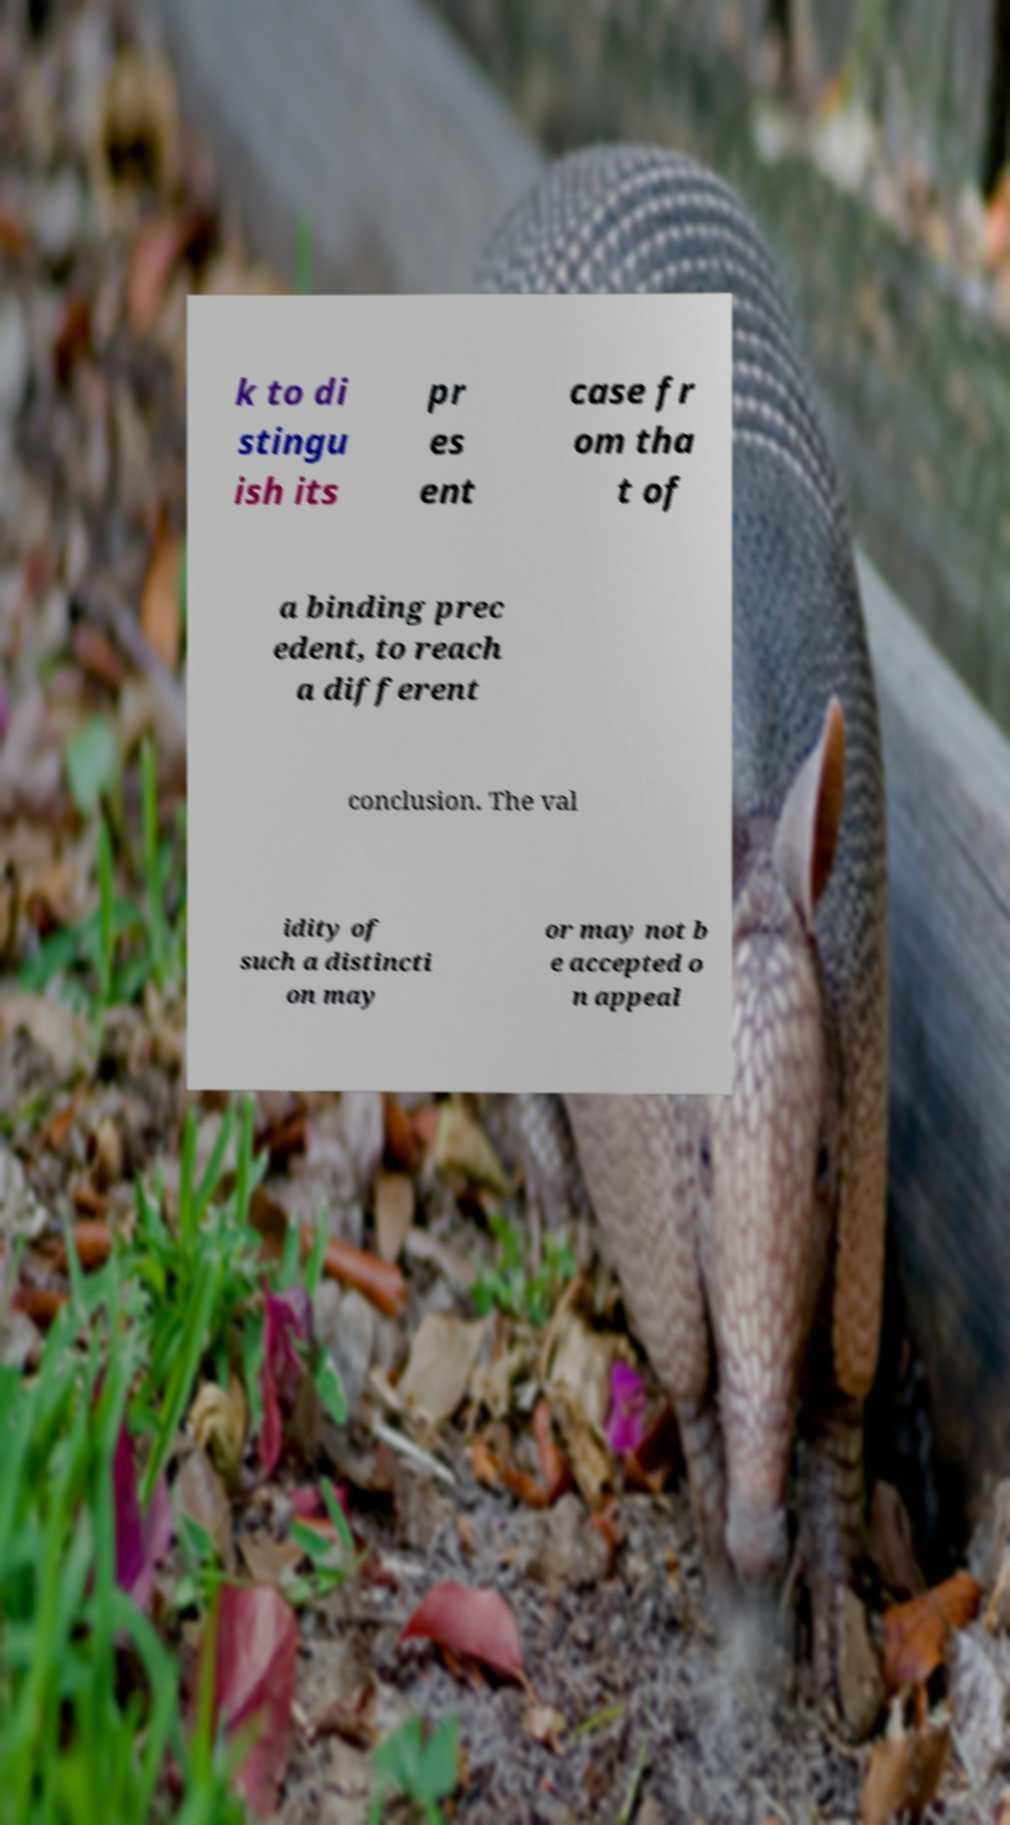Can you accurately transcribe the text from the provided image for me? k to di stingu ish its pr es ent case fr om tha t of a binding prec edent, to reach a different conclusion. The val idity of such a distincti on may or may not b e accepted o n appeal 